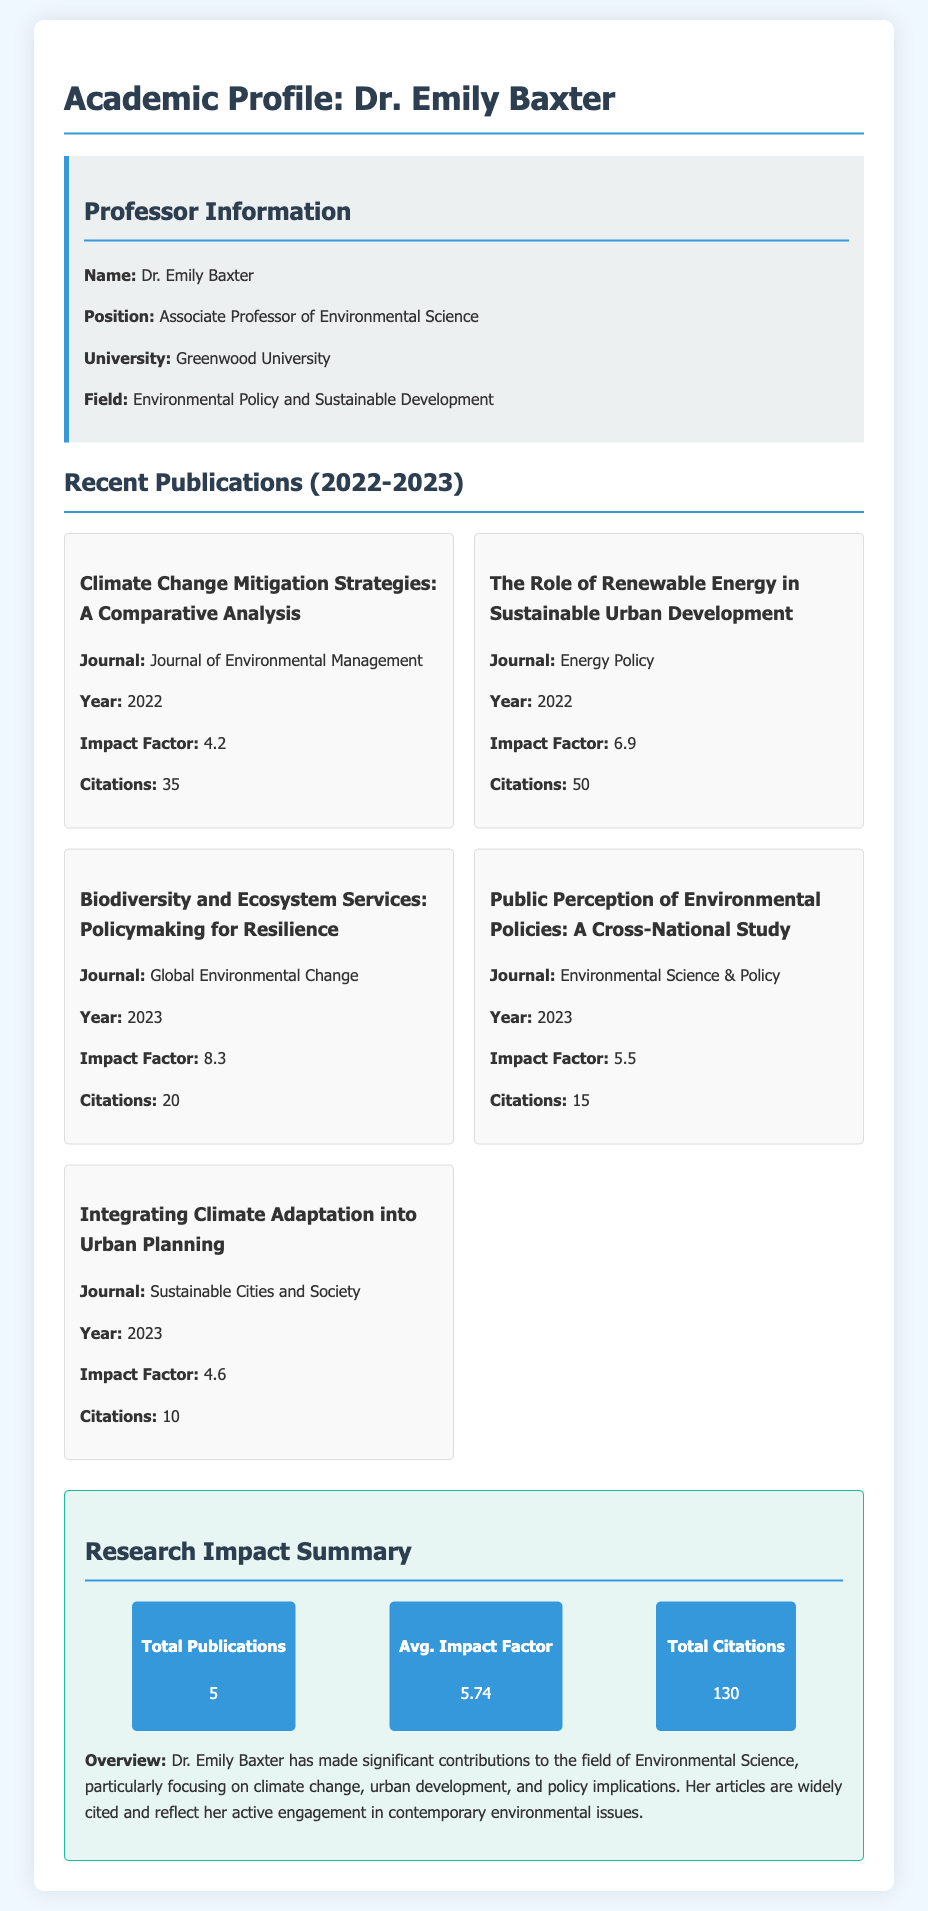What is the name of the professor? The document explicitly states the professor's name as Dr. Emily Baxter.
Answer: Dr. Emily Baxter What is Professor Baxter's position? The document mentions that she holds the position of Associate Professor of Environmental Science.
Answer: Associate Professor of Environmental Science How many publications does Professor Baxter have from 2022 to 2023? The document lists a total of 5 publications in the specified timeframe.
Answer: 5 What is the average impact factor of her publications? The summary in the document provides the average impact factor as 5.74.
Answer: 5.74 Which journal published the paper on renewable energy? The document specifies that "Energy Policy" published the paper titled "The Role of Renewable Energy in Sustainable Urban Development."
Answer: Energy Policy How many citations did "Climate Change Mitigation Strategies" receive? The citations for this publication are clearly stated as 35 in the document.
Answer: 35 What is the impact factor of "Biodiversity and Ecosystem Services"? The document indicates that this publication has an impact factor of 8.3.
Answer: 8.3 What overarching theme do Professor Baxter's articles focus on? The summary highlights her focus on climate change, urban development, and policy implications in environmental science.
Answer: Climate change, urban development, and policy implications What year was "Public Perception of Environmental Policies" published? The document specifies the publication year of this article as 2023.
Answer: 2023 